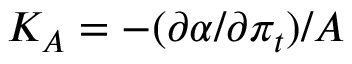Convert formula to latex. <formula><loc_0><loc_0><loc_500><loc_500>K _ { A } = - ( { \partial } \alpha / { \partial } { \pi } _ { t } ) / A</formula> 